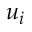<formula> <loc_0><loc_0><loc_500><loc_500>u _ { i }</formula> 